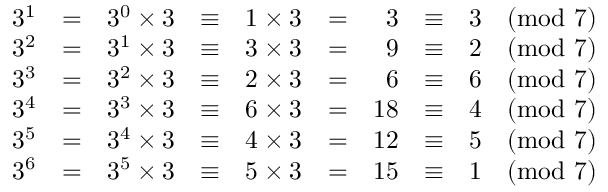Convert formula to latex. <formula><loc_0><loc_0><loc_500><loc_500>{ \begin{array} { r c r c r c r c r c r } { 3 ^ { 1 } } & { = } & { 3 ^ { 0 } \times 3 } & { \equiv } & { 1 \times 3 } & { = } & { 3 } & { \equiv } & { 3 { \pmod { 7 } } } \\ { 3 ^ { 2 } } & { = } & { 3 ^ { 1 } \times 3 } & { \equiv } & { 3 \times 3 } & { = } & { 9 } & { \equiv } & { 2 { \pmod { 7 } } } \\ { 3 ^ { 3 } } & { = } & { 3 ^ { 2 } \times 3 } & { \equiv } & { 2 \times 3 } & { = } & { 6 } & { \equiv } & { 6 { \pmod { 7 } } } \\ { 3 ^ { 4 } } & { = } & { 3 ^ { 3 } \times 3 } & { \equiv } & { 6 \times 3 } & { = } & { 1 8 } & { \equiv } & { 4 { \pmod { 7 } } } \\ { 3 ^ { 5 } } & { = } & { 3 ^ { 4 } \times 3 } & { \equiv } & { 4 \times 3 } & { = } & { 1 2 } & { \equiv } & { 5 { \pmod { 7 } } } \\ { 3 ^ { 6 } } & { = } & { 3 ^ { 5 } \times 3 } & { \equiv } & { 5 \times 3 } & { = } & { 1 5 } & { \equiv } & { 1 { \pmod { 7 } } } \end{array} }</formula> 